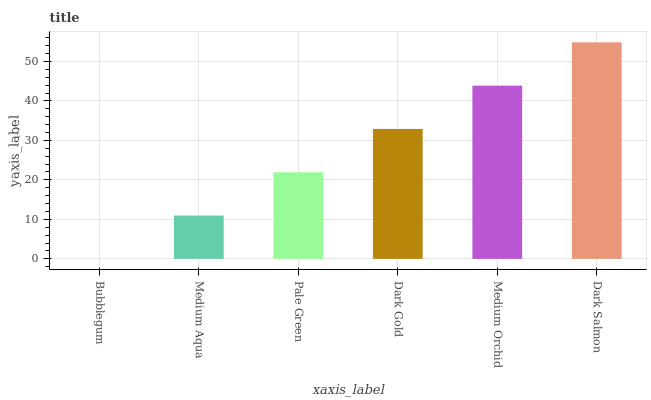Is Bubblegum the minimum?
Answer yes or no. Yes. Is Dark Salmon the maximum?
Answer yes or no. Yes. Is Medium Aqua the minimum?
Answer yes or no. No. Is Medium Aqua the maximum?
Answer yes or no. No. Is Medium Aqua greater than Bubblegum?
Answer yes or no. Yes. Is Bubblegum less than Medium Aqua?
Answer yes or no. Yes. Is Bubblegum greater than Medium Aqua?
Answer yes or no. No. Is Medium Aqua less than Bubblegum?
Answer yes or no. No. Is Dark Gold the high median?
Answer yes or no. Yes. Is Pale Green the low median?
Answer yes or no. Yes. Is Pale Green the high median?
Answer yes or no. No. Is Dark Gold the low median?
Answer yes or no. No. 